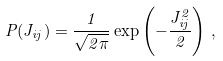Convert formula to latex. <formula><loc_0><loc_0><loc_500><loc_500>P ( J _ { i j } ) = \frac { 1 } { \sqrt { 2 \pi } } \exp \left ( - \frac { J _ { i j } ^ { 2 } } { 2 } \right ) \, ,</formula> 